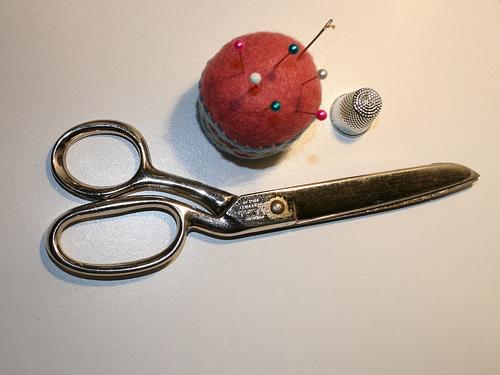What color is the yarn?
Write a very short answer. Red. What is the color of the scissors?
Be succinct. Silver. What color is the thread?
Quick response, please. Red. What activity are these things used for?
Short answer required. Sewing. What is the name of the item to the right of the pincushion?
Keep it brief. Thimble. What animal is on the thimble?
Write a very short answer. None. 